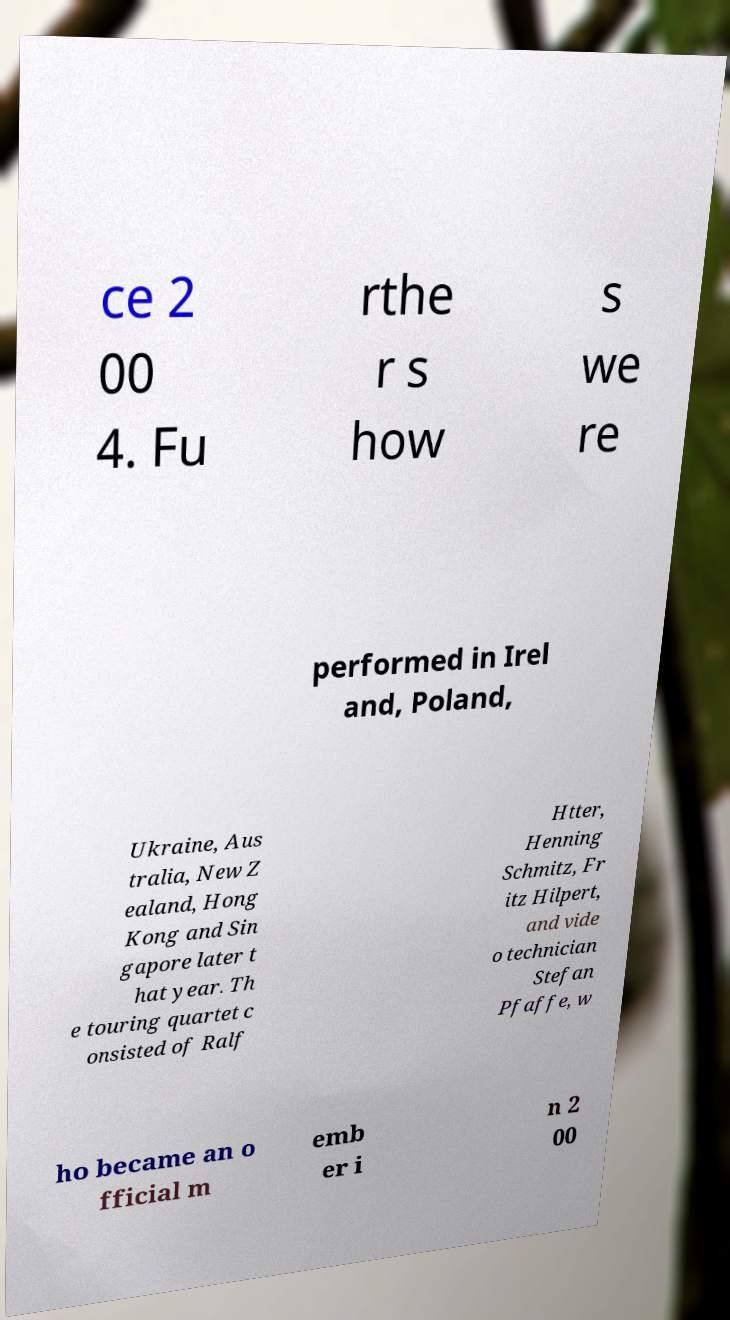I need the written content from this picture converted into text. Can you do that? ce 2 00 4. Fu rthe r s how s we re performed in Irel and, Poland, Ukraine, Aus tralia, New Z ealand, Hong Kong and Sin gapore later t hat year. Th e touring quartet c onsisted of Ralf Htter, Henning Schmitz, Fr itz Hilpert, and vide o technician Stefan Pfaffe, w ho became an o fficial m emb er i n 2 00 